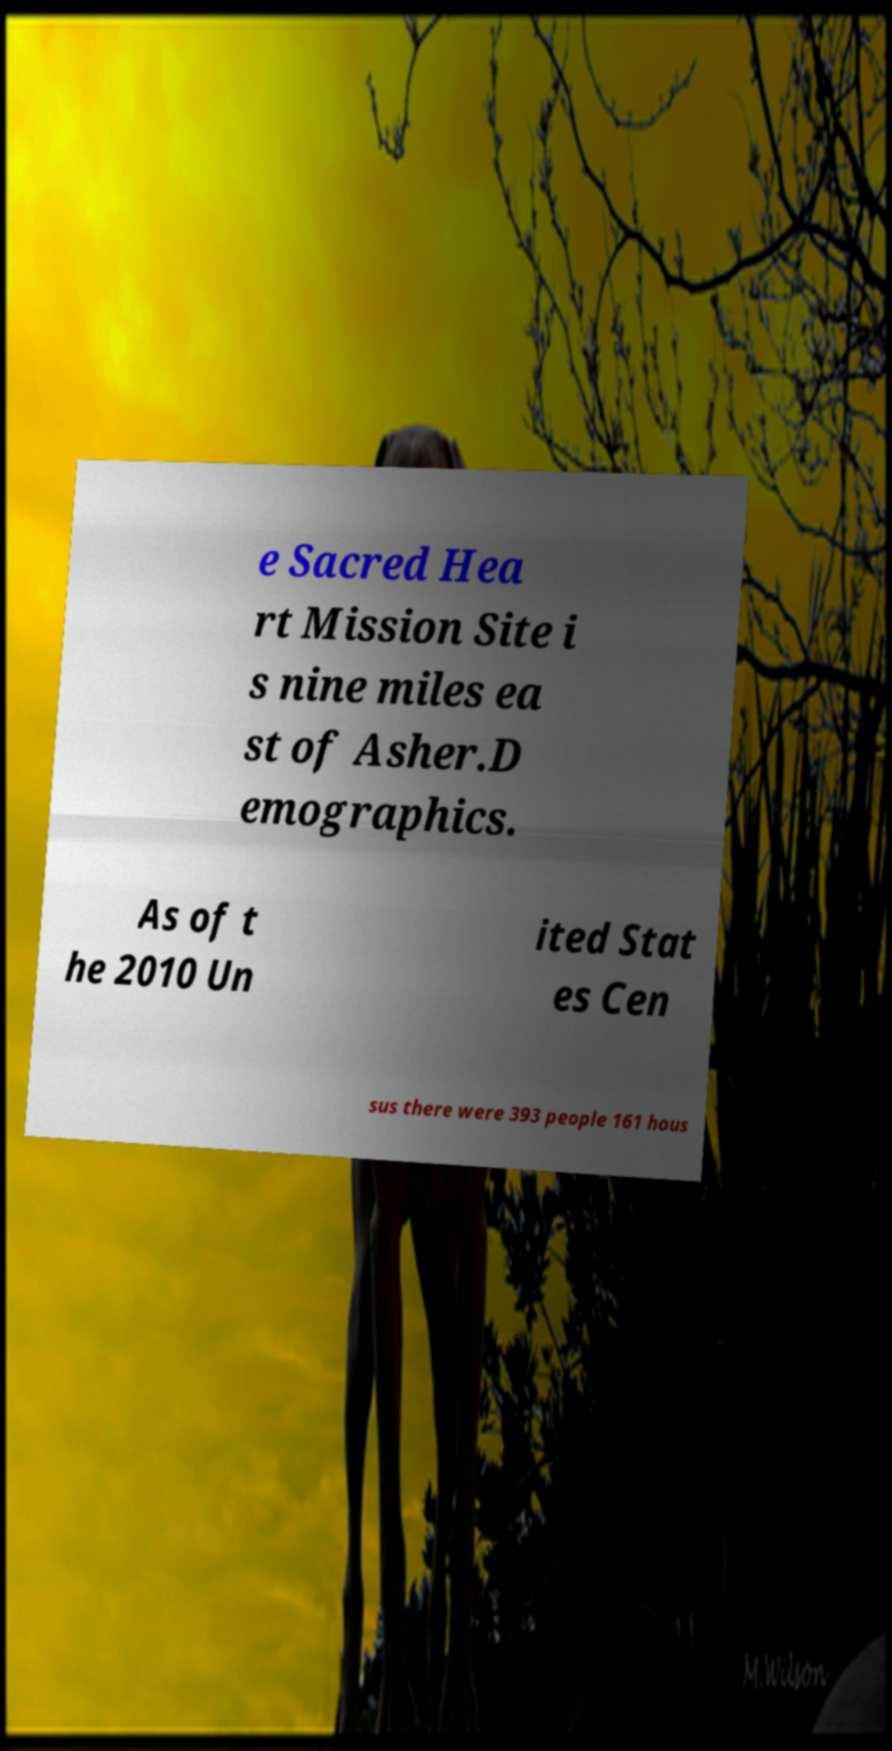I need the written content from this picture converted into text. Can you do that? e Sacred Hea rt Mission Site i s nine miles ea st of Asher.D emographics. As of t he 2010 Un ited Stat es Cen sus there were 393 people 161 hous 